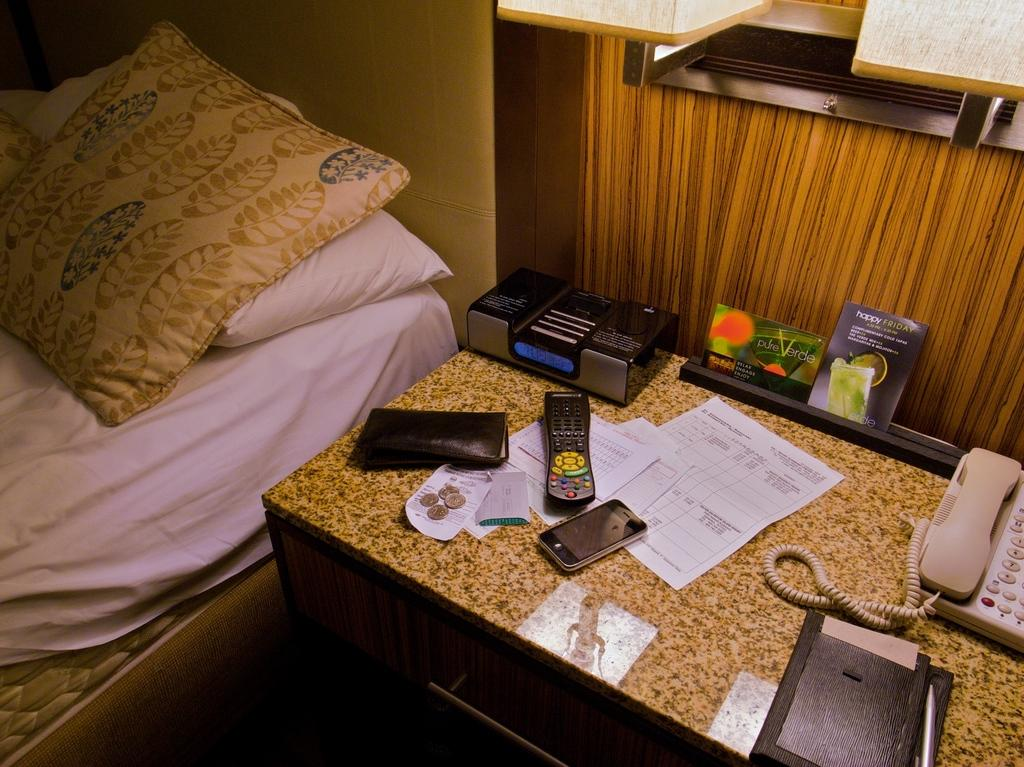What type of furniture is present in the image? There is a bed in the image. What is placed on the bed? There are pillows on the bed. What electronic devices can be seen in the image? There is a mobile phone and a remote in the image. What items related to money are present in the image? There are coins in the image. What type of paper is visible in the image? There is a paper in the image. What communication device is present in the image? There is a telephone in the image. What type of wire is visible in the image? There is a cable wire in the image. What type of reading material is present in the image? There is a book in the image. What writing instrument is present in the image? There is a pen in the image. Are there any other objects present in the image besides those mentioned? Yes, there are other objects in the image. How many cars are parked in the room in the image? There are no cars present in the image. What type of doctor is attending to the patient in the image? There is no doctor or patient present in the image. What type of shake is being prepared in the image? There is no shake being prepared in the image. 